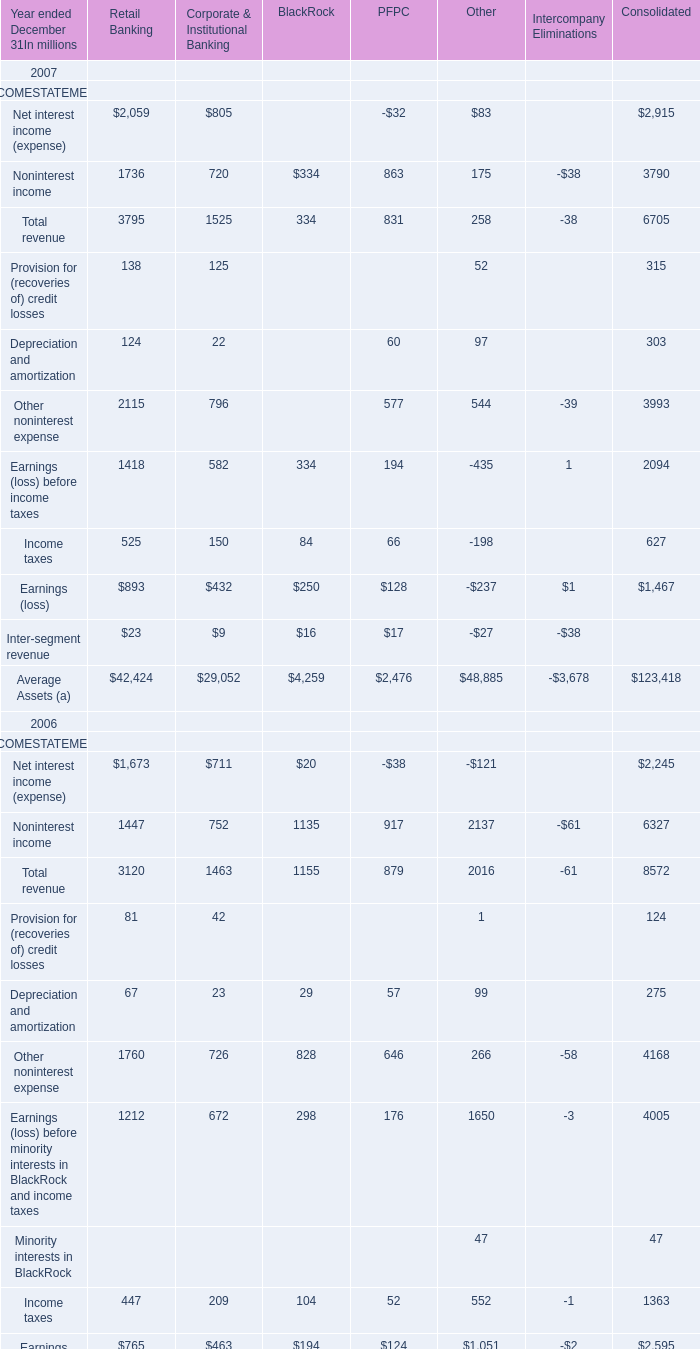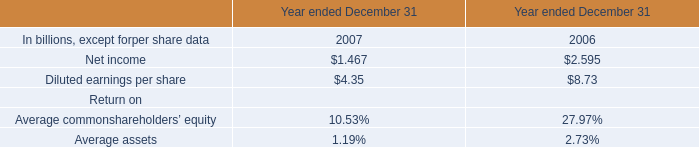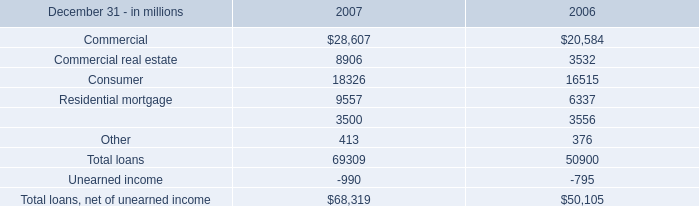In which year ended December 31 is Noninterest income for Corporate & Institutional Banking greater than 750 million? 
Answer: 2006. 